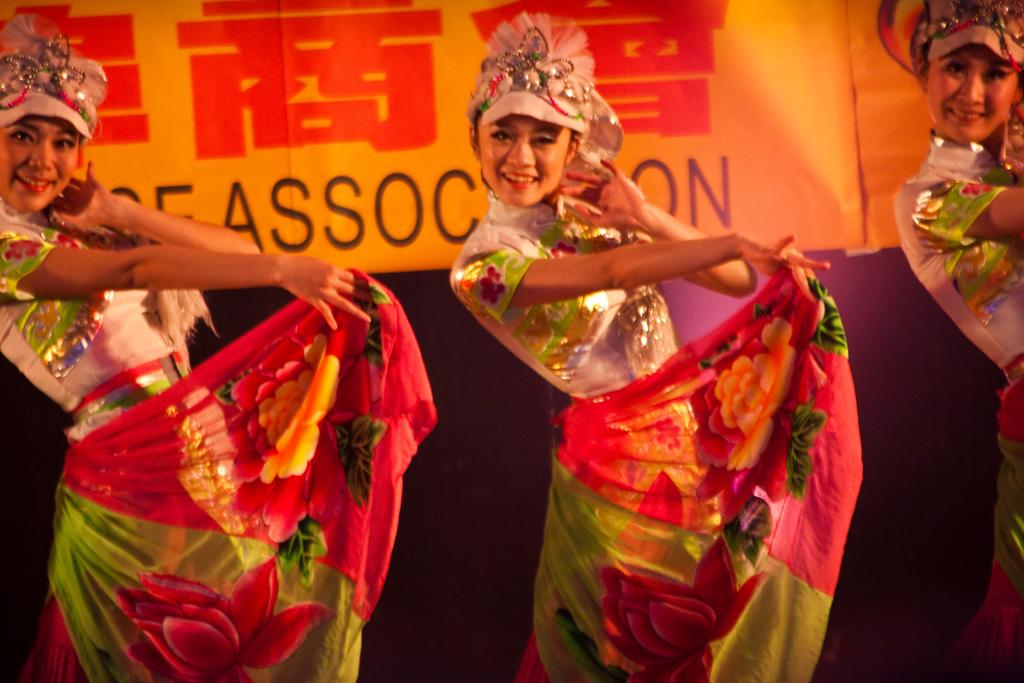Who is present in the image? There are girls in the image. What are the girls doing in the image? The girls are performing a dance. What type of chess piece is being used as a prop during the dance performance? There is no chess piece present in the image, as the girls are performing a dance without any props. 